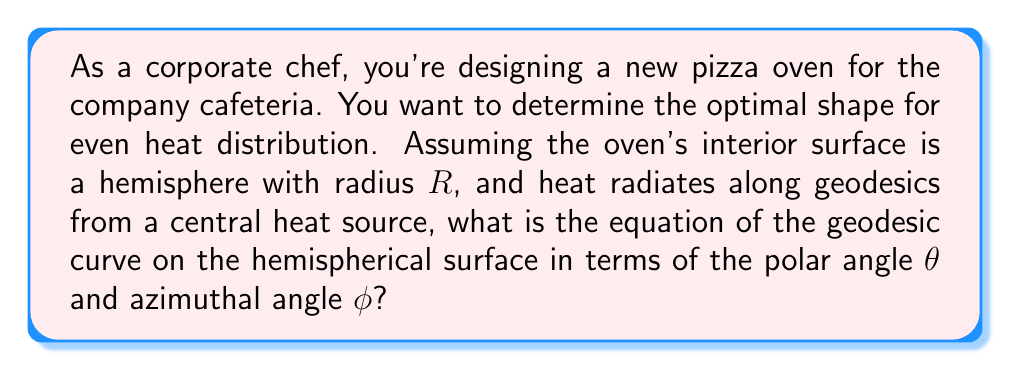Can you answer this question? To solve this problem, we'll follow these steps:

1) Recall that on a sphere, great circles are geodesics. In a hemispherical oven, these will be the paths of even heat distribution.

2) The general equation for a great circle on a sphere in spherical coordinates is:

   $$\cos(\theta) = \sin(\alpha)\sin(\phi-\beta)$$

   Where $\alpha$ is the inclination of the plane of the great circle to the equatorial plane, and $\beta$ is the azimuthal angle of the ascending node.

3) In our case, we're dealing with a hemisphere, so $\theta \in [0, \pi/2]$ and $\phi \in [0, 2\pi]$.

4) For a hemispherical oven, we can assume the heat source is at the center of the base. This means our geodesics will all pass through the pole of the hemisphere.

5) To have the geodesic pass through the pole ($\theta = 0$), we need $\beta = 0$ or $\pi$. Let's choose $\beta = 0$ for simplicity.

6) Our equation now becomes:

   $$\cos(\theta) = \sin(\alpha)\sin(\phi)$$

7) This equation describes all possible geodesics on our hemispherical oven surface, where $\alpha$ determines the specific geodesic.
Answer: $\cos(\theta) = \sin(\alpha)\sin(\phi)$ 